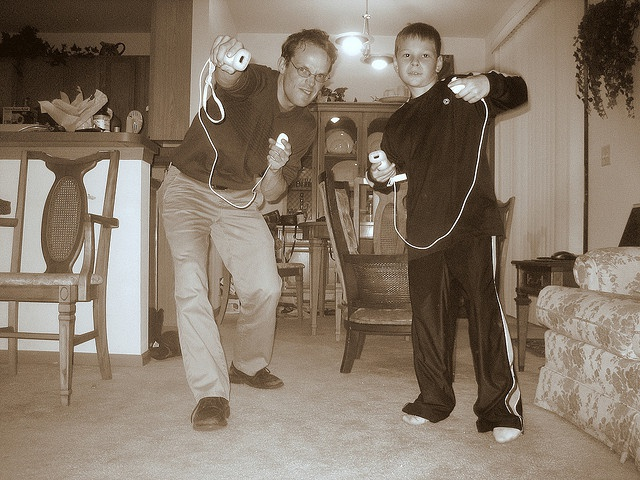Describe the objects in this image and their specific colors. I can see people in black, darkgray, maroon, and gray tones, people in black, darkgray, and maroon tones, chair in black, gray, lightgray, and darkgray tones, couch in black, darkgray, and gray tones, and chair in black, maroon, and gray tones in this image. 